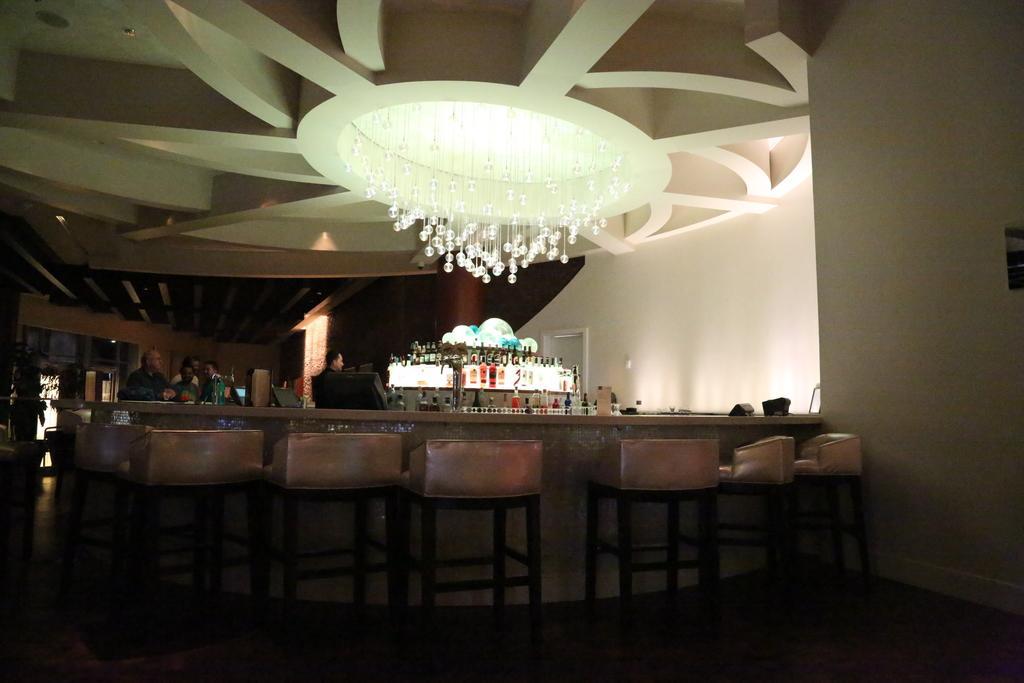Can you describe this image briefly? In the center of the image we can see a counter table and chairs and there are people. We can see bottles placed in the shelf. At the top there is a chandelier. In the background there is a wall and a door. 